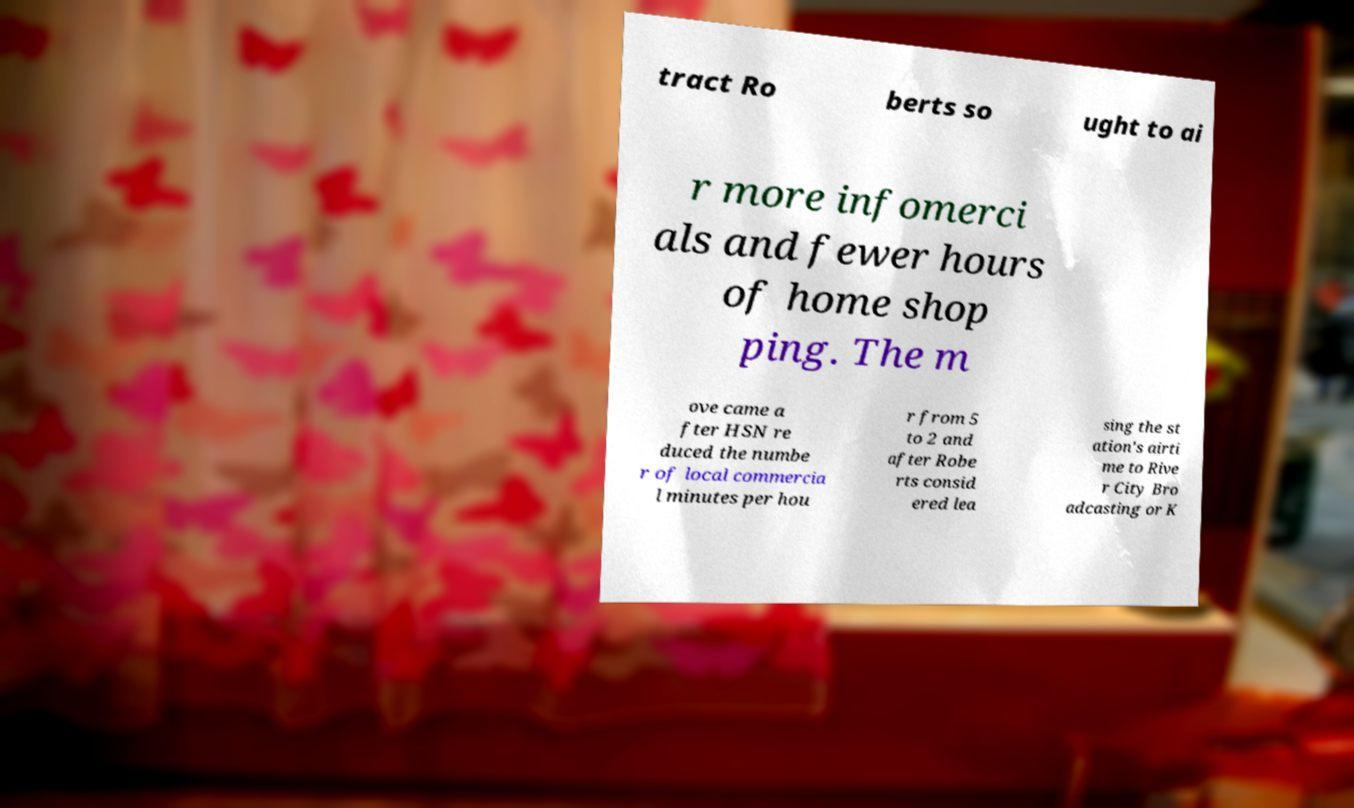Can you read and provide the text displayed in the image?This photo seems to have some interesting text. Can you extract and type it out for me? tract Ro berts so ught to ai r more infomerci als and fewer hours of home shop ping. The m ove came a fter HSN re duced the numbe r of local commercia l minutes per hou r from 5 to 2 and after Robe rts consid ered lea sing the st ation's airti me to Rive r City Bro adcasting or K 